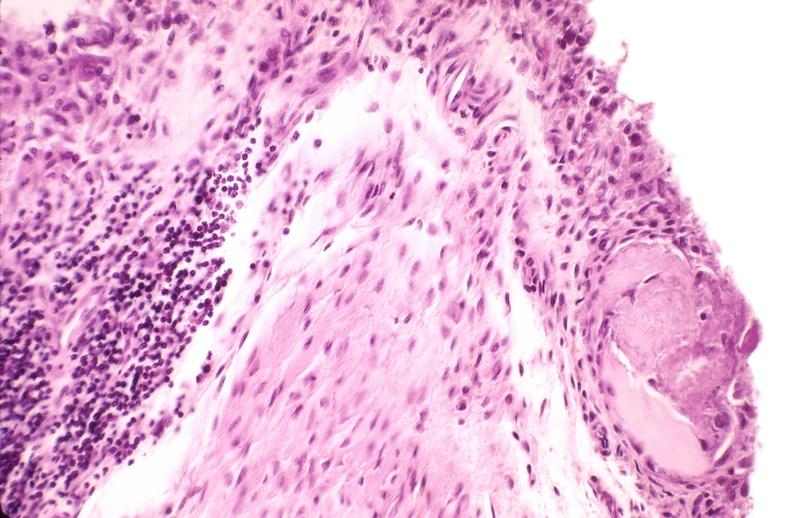does this image show rheumatoid arthritis, synovial hypertrophy with formation of villi pannus?
Answer the question using a single word or phrase. Yes 